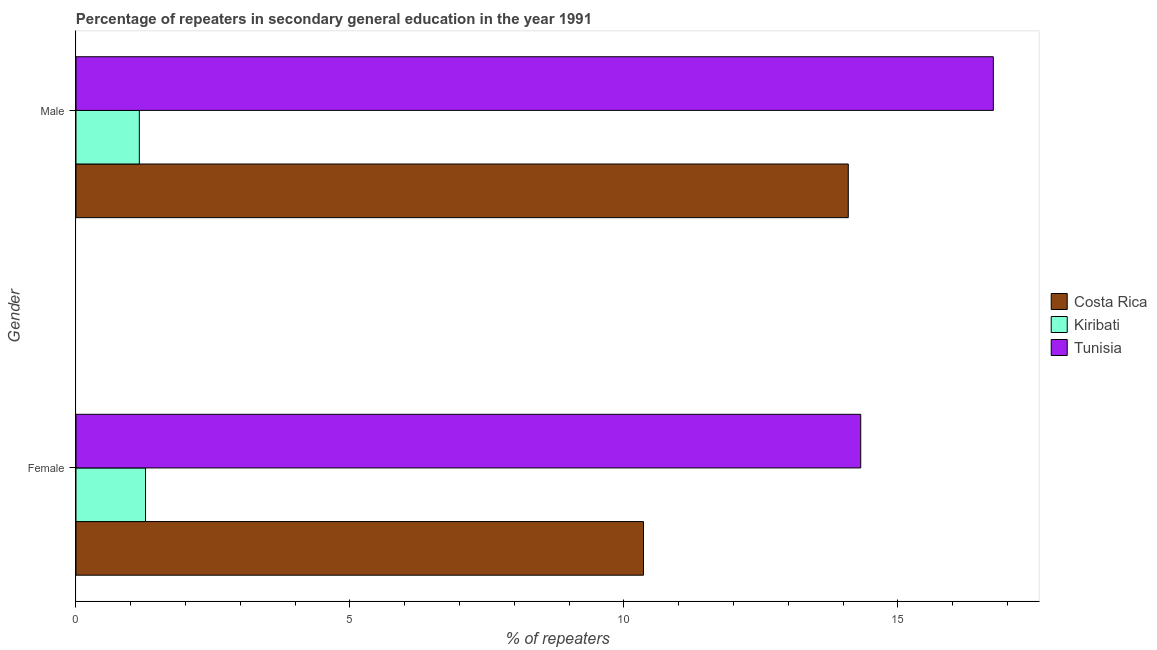How many different coloured bars are there?
Your response must be concise. 3. How many groups of bars are there?
Ensure brevity in your answer.  2. Are the number of bars on each tick of the Y-axis equal?
Your answer should be very brief. Yes. How many bars are there on the 1st tick from the top?
Your response must be concise. 3. How many bars are there on the 1st tick from the bottom?
Offer a very short reply. 3. What is the percentage of male repeaters in Tunisia?
Offer a very short reply. 16.74. Across all countries, what is the maximum percentage of male repeaters?
Give a very brief answer. 16.74. Across all countries, what is the minimum percentage of female repeaters?
Give a very brief answer. 1.27. In which country was the percentage of male repeaters maximum?
Keep it short and to the point. Tunisia. In which country was the percentage of female repeaters minimum?
Your answer should be compact. Kiribati. What is the total percentage of female repeaters in the graph?
Ensure brevity in your answer.  25.95. What is the difference between the percentage of female repeaters in Tunisia and that in Costa Rica?
Your answer should be compact. 3.96. What is the difference between the percentage of female repeaters in Costa Rica and the percentage of male repeaters in Tunisia?
Your response must be concise. -6.38. What is the average percentage of female repeaters per country?
Your response must be concise. 8.65. What is the difference between the percentage of male repeaters and percentage of female repeaters in Tunisia?
Give a very brief answer. 2.42. What is the ratio of the percentage of female repeaters in Tunisia to that in Kiribati?
Keep it short and to the point. 11.28. In how many countries, is the percentage of female repeaters greater than the average percentage of female repeaters taken over all countries?
Give a very brief answer. 2. What does the 1st bar from the bottom in Male represents?
Make the answer very short. Costa Rica. How many bars are there?
Provide a succinct answer. 6. How many countries are there in the graph?
Your answer should be compact. 3. Does the graph contain any zero values?
Your response must be concise. No. Does the graph contain grids?
Your answer should be compact. No. What is the title of the graph?
Ensure brevity in your answer.  Percentage of repeaters in secondary general education in the year 1991. Does "Northern Mariana Islands" appear as one of the legend labels in the graph?
Offer a terse response. No. What is the label or title of the X-axis?
Ensure brevity in your answer.  % of repeaters. What is the % of repeaters of Costa Rica in Female?
Keep it short and to the point. 10.36. What is the % of repeaters in Kiribati in Female?
Your answer should be compact. 1.27. What is the % of repeaters of Tunisia in Female?
Offer a very short reply. 14.32. What is the % of repeaters of Costa Rica in Male?
Your answer should be compact. 14.09. What is the % of repeaters of Kiribati in Male?
Provide a short and direct response. 1.16. What is the % of repeaters of Tunisia in Male?
Provide a short and direct response. 16.74. Across all Gender, what is the maximum % of repeaters of Costa Rica?
Ensure brevity in your answer.  14.09. Across all Gender, what is the maximum % of repeaters in Kiribati?
Offer a terse response. 1.27. Across all Gender, what is the maximum % of repeaters of Tunisia?
Offer a terse response. 16.74. Across all Gender, what is the minimum % of repeaters in Costa Rica?
Offer a very short reply. 10.36. Across all Gender, what is the minimum % of repeaters of Kiribati?
Provide a succinct answer. 1.16. Across all Gender, what is the minimum % of repeaters of Tunisia?
Your response must be concise. 14.32. What is the total % of repeaters of Costa Rica in the graph?
Give a very brief answer. 24.45. What is the total % of repeaters of Kiribati in the graph?
Provide a succinct answer. 2.42. What is the total % of repeaters of Tunisia in the graph?
Offer a very short reply. 31.06. What is the difference between the % of repeaters of Costa Rica in Female and that in Male?
Your answer should be very brief. -3.74. What is the difference between the % of repeaters of Kiribati in Female and that in Male?
Your answer should be compact. 0.11. What is the difference between the % of repeaters in Tunisia in Female and that in Male?
Your response must be concise. -2.42. What is the difference between the % of repeaters in Costa Rica in Female and the % of repeaters in Kiribati in Male?
Provide a succinct answer. 9.2. What is the difference between the % of repeaters of Costa Rica in Female and the % of repeaters of Tunisia in Male?
Offer a terse response. -6.38. What is the difference between the % of repeaters of Kiribati in Female and the % of repeaters of Tunisia in Male?
Offer a terse response. -15.47. What is the average % of repeaters of Costa Rica per Gender?
Provide a short and direct response. 12.23. What is the average % of repeaters of Kiribati per Gender?
Your answer should be compact. 1.21. What is the average % of repeaters of Tunisia per Gender?
Your answer should be compact. 15.53. What is the difference between the % of repeaters of Costa Rica and % of repeaters of Kiribati in Female?
Offer a terse response. 9.09. What is the difference between the % of repeaters of Costa Rica and % of repeaters of Tunisia in Female?
Offer a very short reply. -3.96. What is the difference between the % of repeaters in Kiribati and % of repeaters in Tunisia in Female?
Offer a terse response. -13.05. What is the difference between the % of repeaters of Costa Rica and % of repeaters of Kiribati in Male?
Your answer should be compact. 12.94. What is the difference between the % of repeaters of Costa Rica and % of repeaters of Tunisia in Male?
Give a very brief answer. -2.65. What is the difference between the % of repeaters of Kiribati and % of repeaters of Tunisia in Male?
Make the answer very short. -15.59. What is the ratio of the % of repeaters of Costa Rica in Female to that in Male?
Offer a terse response. 0.73. What is the ratio of the % of repeaters of Kiribati in Female to that in Male?
Your response must be concise. 1.1. What is the ratio of the % of repeaters in Tunisia in Female to that in Male?
Make the answer very short. 0.86. What is the difference between the highest and the second highest % of repeaters in Costa Rica?
Provide a short and direct response. 3.74. What is the difference between the highest and the second highest % of repeaters in Kiribati?
Your answer should be very brief. 0.11. What is the difference between the highest and the second highest % of repeaters in Tunisia?
Make the answer very short. 2.42. What is the difference between the highest and the lowest % of repeaters in Costa Rica?
Offer a terse response. 3.74. What is the difference between the highest and the lowest % of repeaters in Kiribati?
Keep it short and to the point. 0.11. What is the difference between the highest and the lowest % of repeaters of Tunisia?
Give a very brief answer. 2.42. 